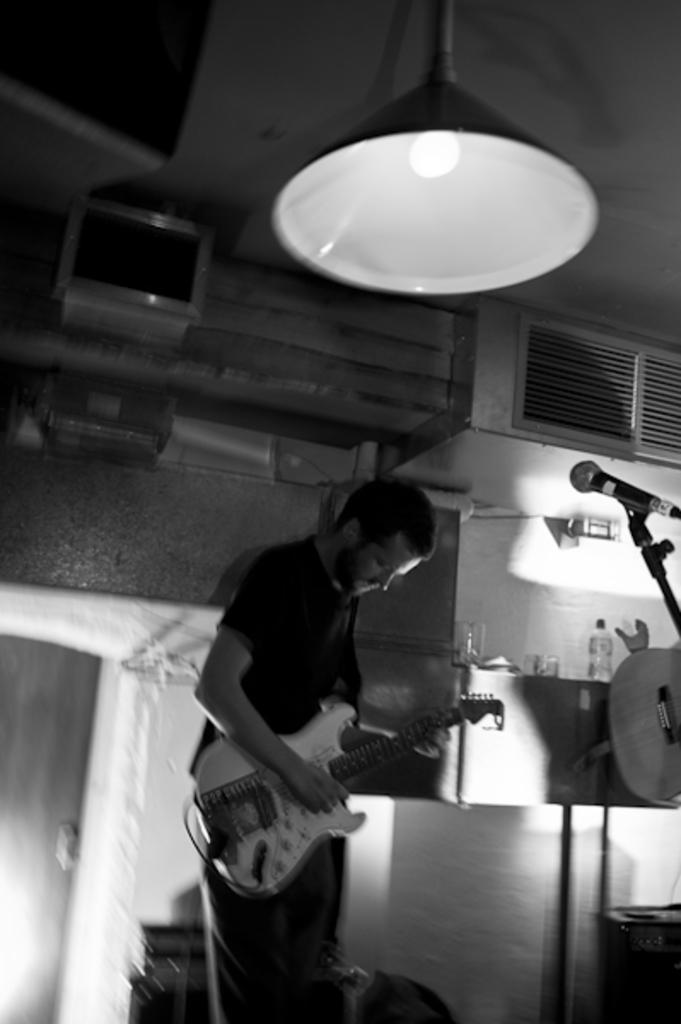What is the person in the image doing? The person is standing in the image and holding a guitar. What object is present in the image that is commonly used for amplifying sound? There is a microphone with a stand in the image. What architectural features can be seen in the background of the image? There is a wall and a door in the background of the image. What can be found on the table in the background of the image? There is a bottle in the background of the image. What is the source of illumination visible at the top of the image? There is a light visible at the top of the image. How does the person in the image help the students during recess? The image does not depict a person helping students during recess; it shows a person holding a guitar and standing near a microphone. 